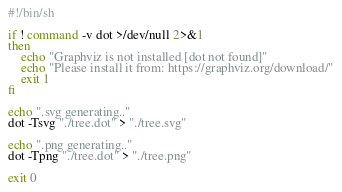Convert code to text. <code><loc_0><loc_0><loc_500><loc_500><_Bash_>#!/bin/sh

if ! command -v dot >/dev/null 2>&1
then
    echo "Graphviz is not installed [dot not found]"
	echo "Please install it from: https://graphviz.org/download/"
    exit 1
fi

echo ".svg generating.."
dot -Tsvg "./tree.dot" > "./tree.svg"

echo ".png generating.."
dot -Tpng "./tree.dot" > "./tree.png"

exit 0
</code> 